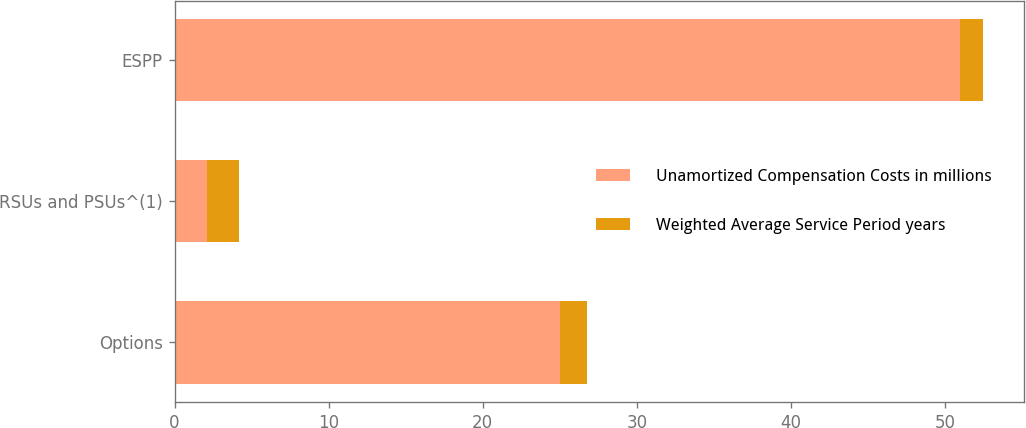<chart> <loc_0><loc_0><loc_500><loc_500><stacked_bar_chart><ecel><fcel>Options<fcel>RSUs and PSUs^(1)<fcel>ESPP<nl><fcel>Unamortized Compensation Costs in millions<fcel>25<fcel>2.1<fcel>51<nl><fcel>Weighted Average Service Period years<fcel>1.8<fcel>2.1<fcel>1.5<nl></chart> 